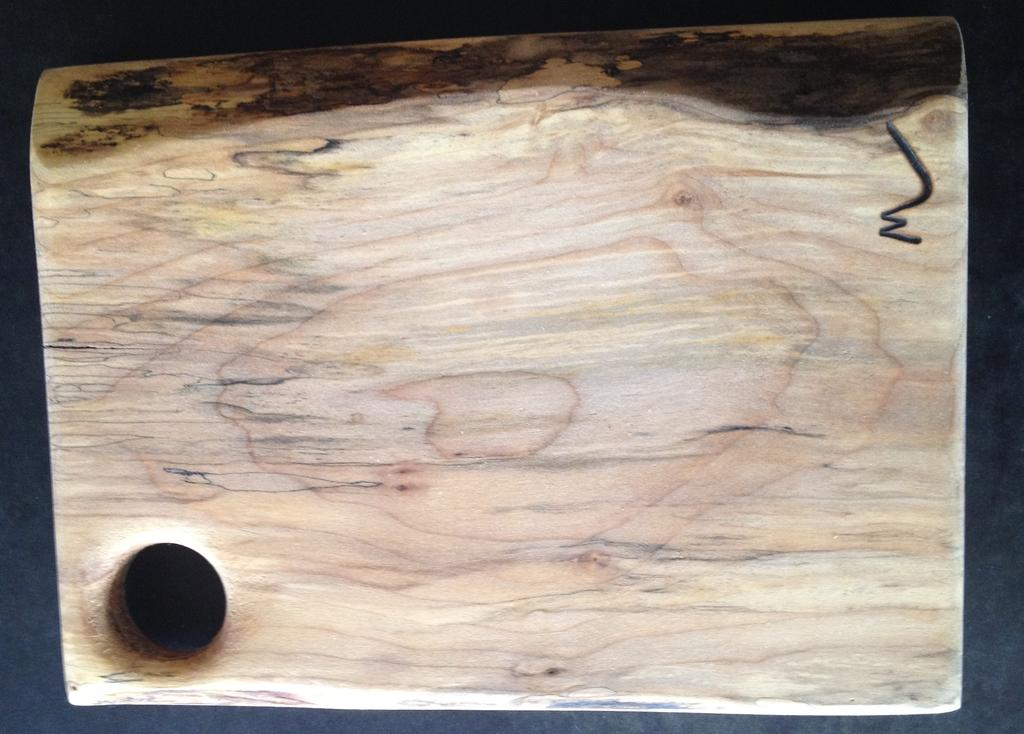What material is the object in the image made of? The object in the image is made of wood. Where is the wooden object located in the image? The wooden piece is kept on the floor. How does the wooden piece generate steam in the image? The wooden piece does not generate steam in the image, as there is no indication of any steam-producing mechanism or activity. 